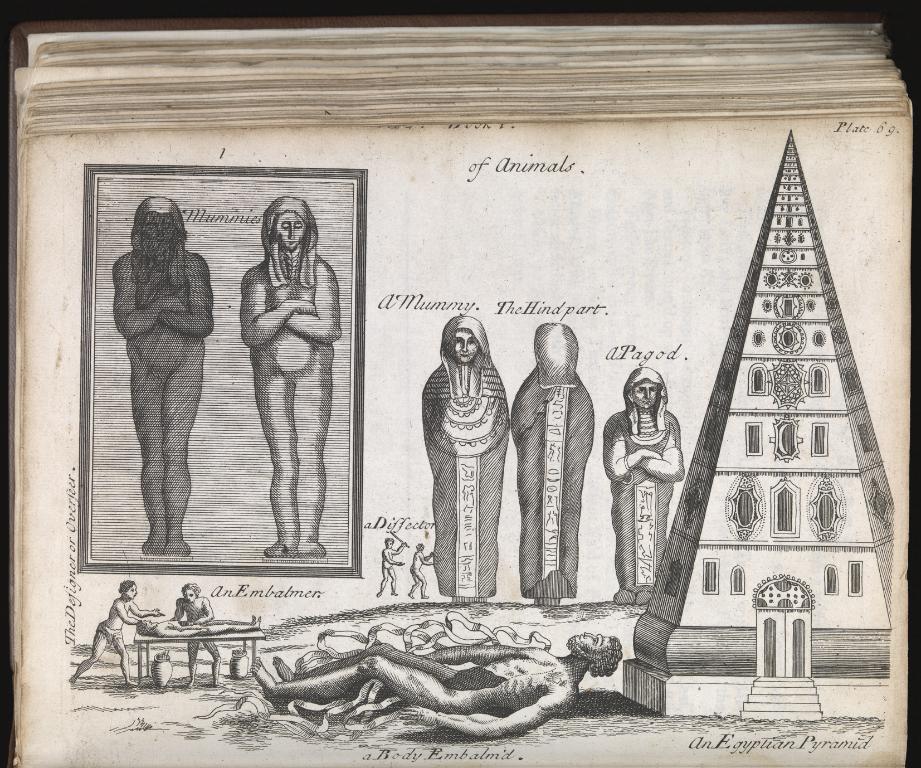In one or two sentences, can you explain what this image depicts? In this picture, we see the book and a paper on which the mummies and a building are drawn. 